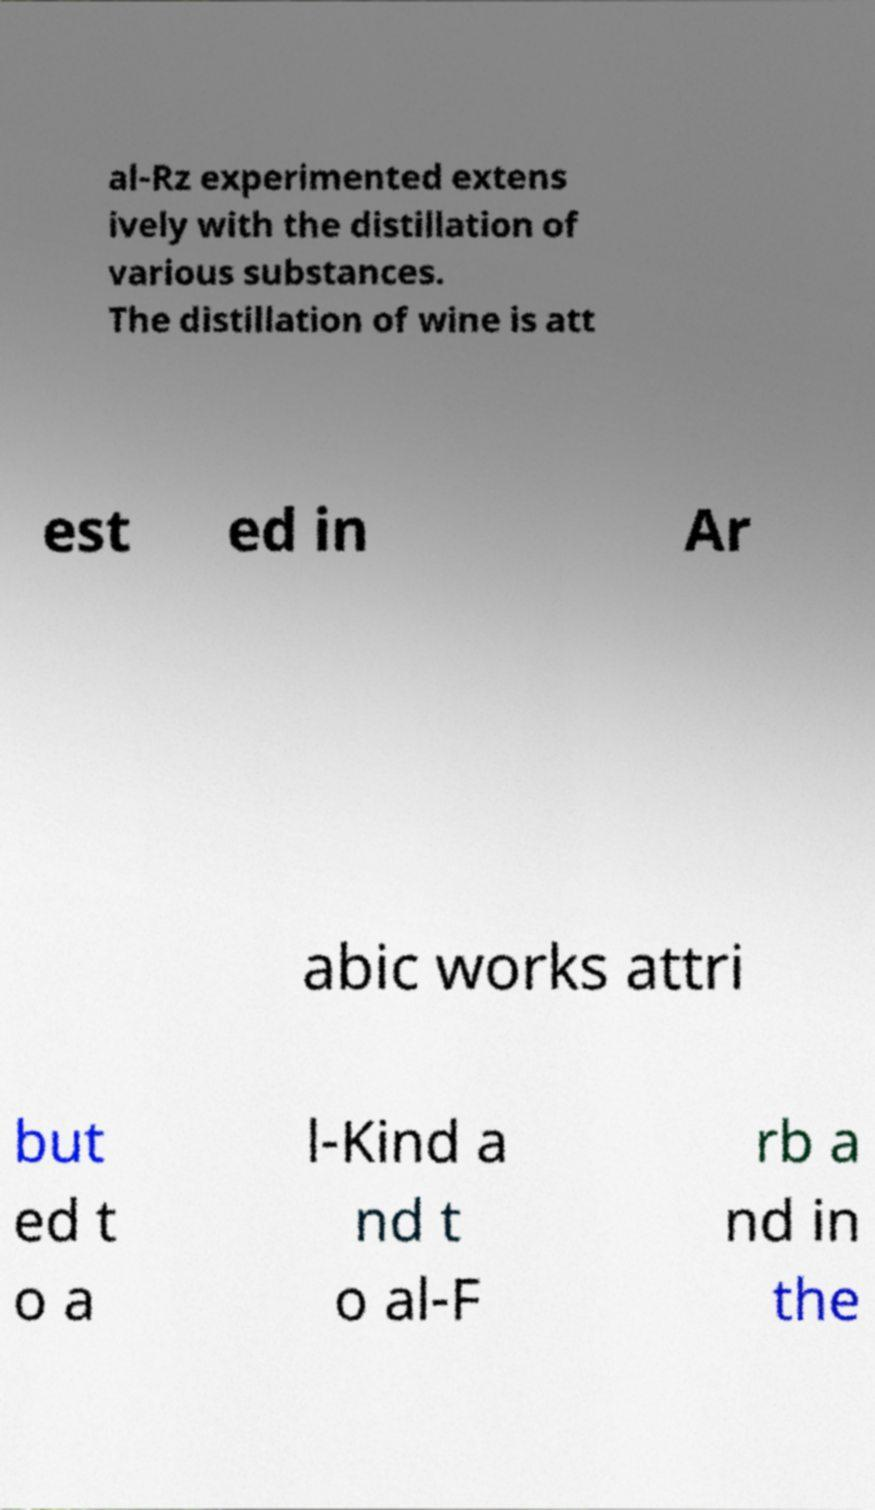There's text embedded in this image that I need extracted. Can you transcribe it verbatim? al-Rz experimented extens ively with the distillation of various substances. The distillation of wine is att est ed in Ar abic works attri but ed t o a l-Kind a nd t o al-F rb a nd in the 